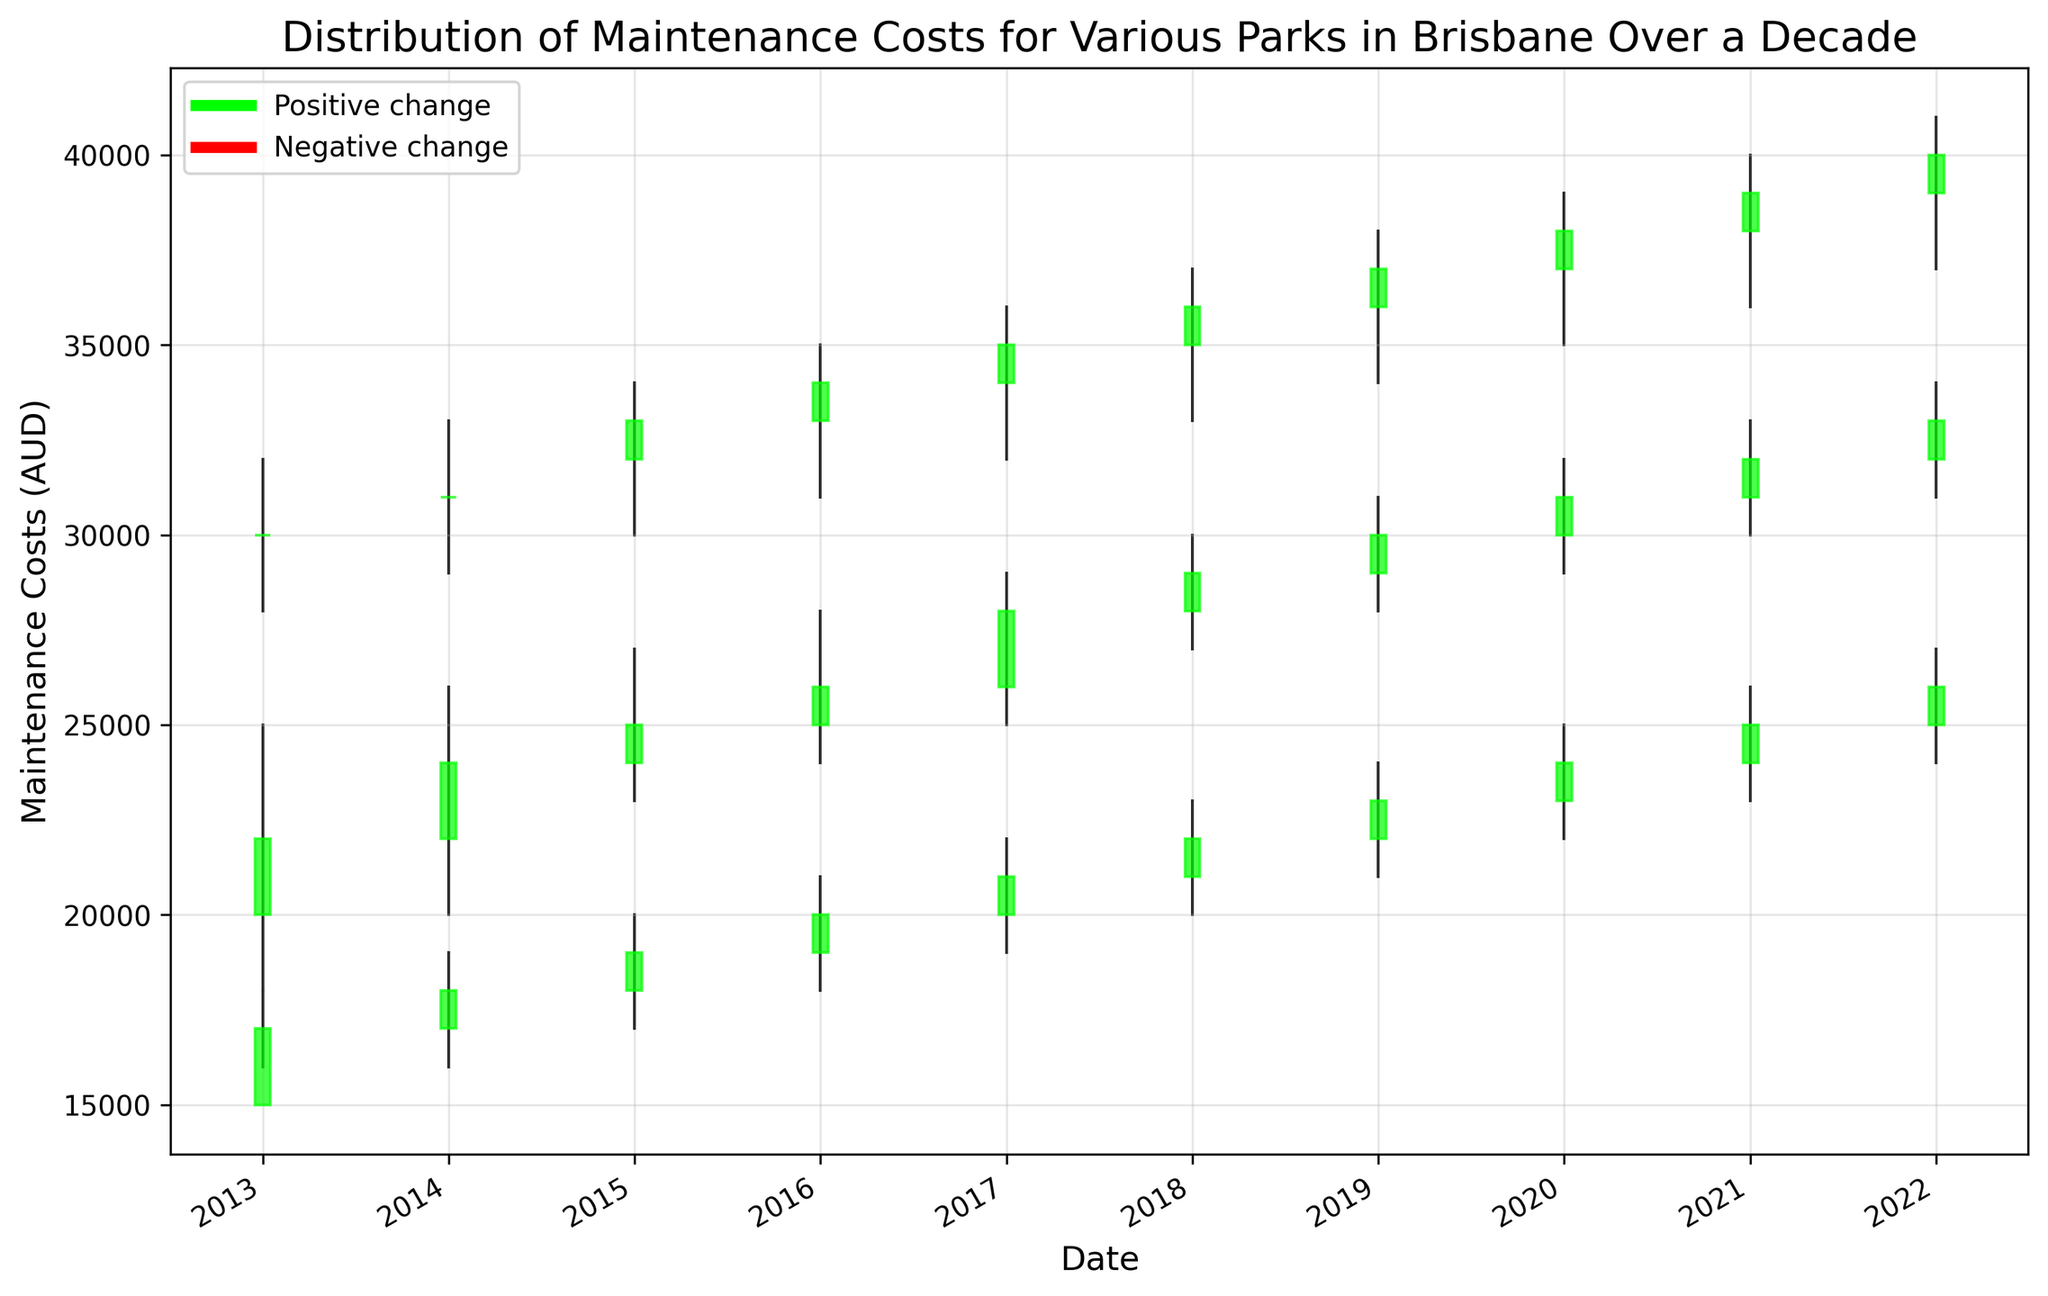What trend do you observe in the maintenance costs for Park A from 2013 to 2022? To observe the trend, check the closing values for Park A from 2013 to 2022. They consistently increase from 22000 in 2013 to 33000 in 2022. This indicates a rising trend in maintenance costs for Park A over the decade.
Answer: Rising trend Which park experienced the highest maintenance cost in 2022? Check the closing values of all parks in 2022. Park C has the highest closing value of 40000.
Answer: Park C Did Park B experience a positive or negative change in maintenance costs from 2019 to 2020? Compare the closing value of Park B in 2019 (23000) with the opening value in 2020 (23000). Since the closing value in 2020 (24000) is higher than the opening value in 2020, it indicates a positive change.
Answer: Positive change In which year did Park C first reach a closing maintenance cost of 35000 or more? Review the closing values of Park C across the years. Park C first reached a closing value of 35000 in 2017.
Answer: 2017 What was the difference in maintenance costs for Park A between 2015 and 2016? Calculate the difference between the closing values for Park A in 2015 (25000) and 2016 (26000). This gives 26000 - 25000 = 1000.
Answer: 1000 How many times did Park B's maintenance costs decrease over the decade? Count the years where the closing value is less than the opening value for Park B. This occurred in 2013, 2016, 2019.
Answer: 3 times Between 2016 and 2017, which park experienced the largest increase in maintenance costs? Compare the differences in closing values between 2016 and 2017 for all parks. For Park A: 28000 - 26000 = 2000, Park B: 21000 - 20000 = 1000, Park C: 35000 - 34000 = 1000. Park A has the largest increase.
Answer: Park A What was the average closing maintenance cost for Park C during the first five years? Average the closing values for Park C from 2013 to 2017 (30000, 31000, 33000, 34000, 35000). (30000 + 31000 + 33000 + 34000 + 35000)/5 = 32600.
Answer: 32600 Which year had the smallest range in maintenance costs for Park A? Calculate the range (high - low) for Park A each year and find the smallest. 2013: 25000 - 18000 = 7000, 2014: 26000 - 20000 = 6000, 2015: 27000 - 23000 = 4000, 2016: 28000 - 24000 = 4000, 2017: 29000 - 25000 = 4000, 2018: 30000 - 27000 = 3000, 2019: 31000 - 28000 = 3000, 2020: 32000 - 29000 = 3000, 2021: 33000 - 30000 = 3000, 2022: 34000 - 31000 = 3000. The smallest range is for the years 2018, 2019, 2020, 2021, and 2022, all with a range of 3000.
Answer: 2018, 2019, 2020, 2021, 2022 